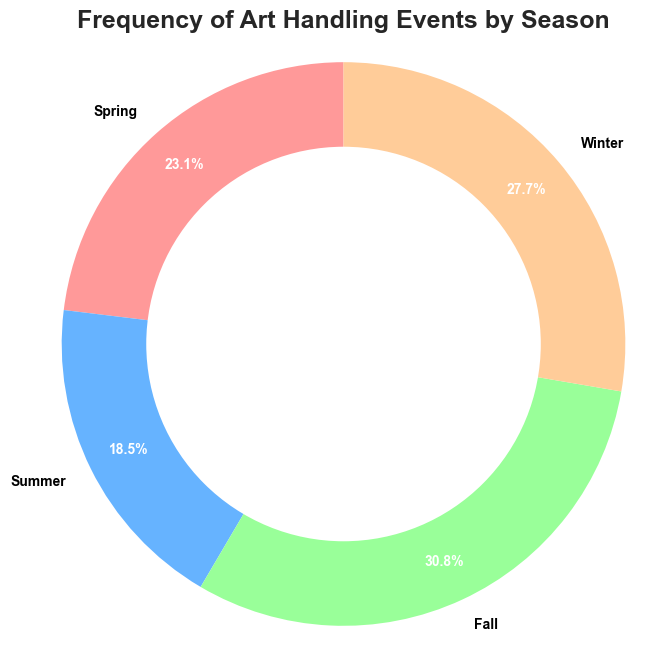Which season has the highest frequency of art handling events? By looking at the pie chart and the respective percentages, we can identify that the season with the largest slice represents the highest frequency.
Answer: Fall Which season has the lowest frequency of art handling events? By observing the pie chart, the smallest slice will correspond to the season with the lowest frequency.
Answer: Summer What is the total frequency of art handling events in spring and summer combined? According to the pie chart, spring has 150 events and summer has 120 events. Adding these gives us 150 + 120 = 270.
Answer: 270 How does the frequency of art handling events in winter compare to that in summer? The pie chart shows winter with more events than summer. Specifically, winter has 180 events, while summer has 120 events.
Answer: Winter has more What percentage of art handling events occur in fall? The pie chart shows the percentage values for each segment. The value for fall is 200 out of a total of 650 (150+120+200+180) events, which is approximately (200/650)*100 ≈ 30.8%.
Answer: Approximately 30.8% What is the combined percentage of art handling events in spring and winter? Adding the percentages shown on the pie chart for spring and winter: Spring (approximated as 23.1%) and Winter (approximated as 27.7%). The total is 23.1% + 27.7% ≈ 50.8%.
Answer: Approximately 50.8% If the frequency of events in summer doubled, how would it compare to the current frequency in fall? Currently, summer has 120 events. If doubled, it would have 240 events, which would surpass fall's 200 events.
Answer: Summer would have more What percentage of art handling events do spring and fall together account for? Spring has 150 events and fall has 200 events. Combined, they have 350 events out of 650 total events, which is approximately (350/650)*100 ≈ 53.8%.
Answer: Approximately 53.8% Which seasons have frequencies that sum up to more than half of the total events? By combining the season frequencies: Spring (150) + Fall (200) = 350, which is more than half of the total (650). Also, Winter (180) + Fall (200) = 380.
Answer: Spring and Fall; Winter and Fall What is the difference in the number of art handling events between fall and summer? Fall has 200 events and summer has 120 events. The difference is 200 - 120 = 80.
Answer: 80 